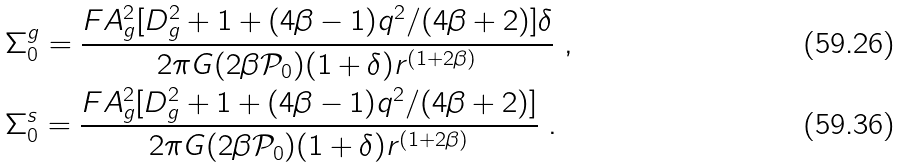Convert formula to latex. <formula><loc_0><loc_0><loc_500><loc_500>& \Sigma _ { 0 } ^ { g } = \frac { F A _ { g } ^ { 2 } [ D _ { g } ^ { 2 } + 1 + ( 4 \beta - 1 ) q ^ { 2 } / ( 4 \beta + 2 ) ] \delta } { 2 \pi G ( 2 \beta \mathcal { P } _ { 0 } ) ( 1 + \delta ) r ^ { ( 1 + 2 \beta ) } } \ , \\ & \Sigma _ { 0 } ^ { s } = \frac { F A _ { g } ^ { 2 } [ D _ { g } ^ { 2 } + 1 + ( 4 \beta - 1 ) q ^ { 2 } / ( 4 \beta + 2 ) ] } { 2 \pi G ( 2 \beta \mathcal { P } _ { 0 } ) ( 1 + \delta ) r ^ { ( 1 + 2 \beta ) } } \ .</formula> 